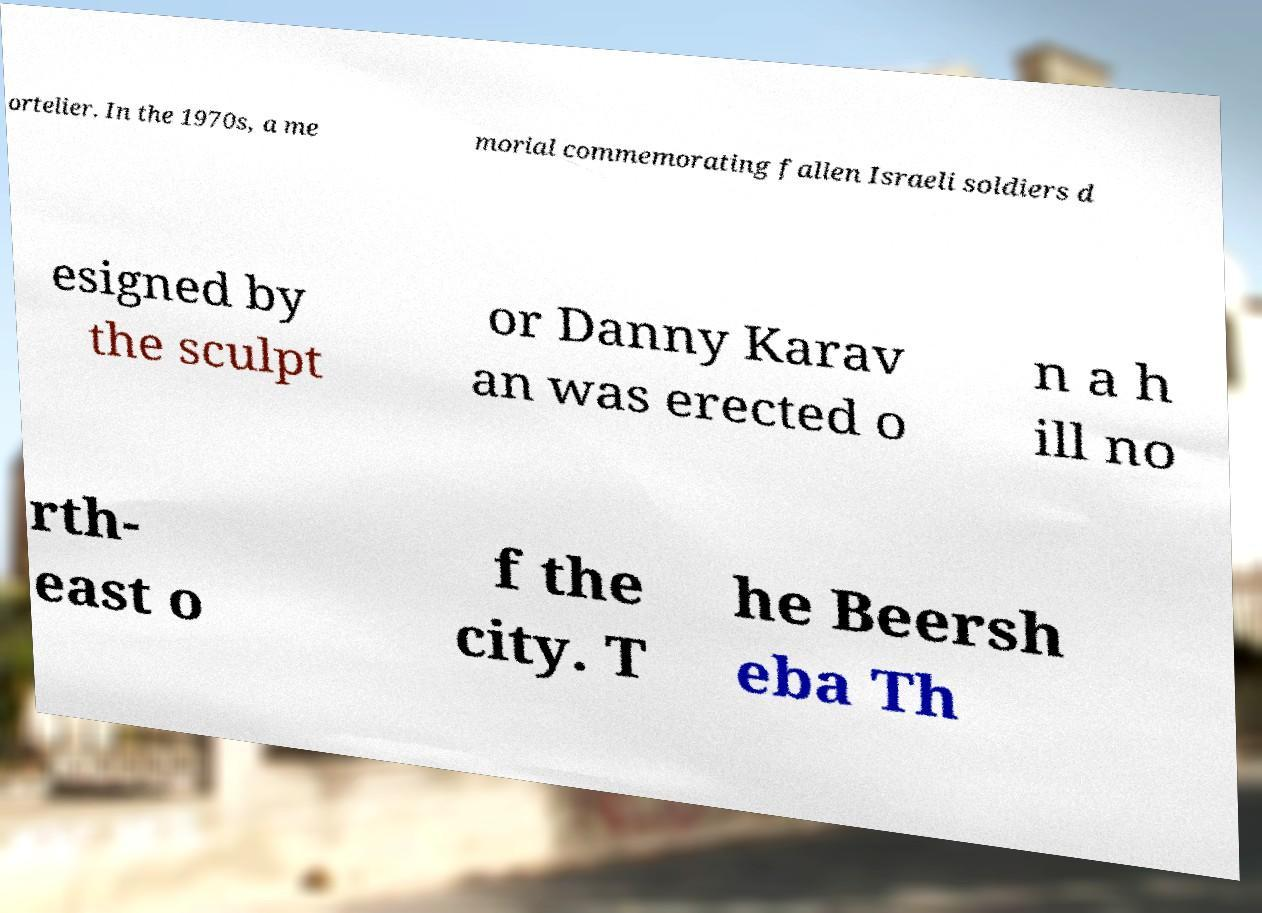Could you assist in decoding the text presented in this image and type it out clearly? ortelier. In the 1970s, a me morial commemorating fallen Israeli soldiers d esigned by the sculpt or Danny Karav an was erected o n a h ill no rth- east o f the city. T he Beersh eba Th 